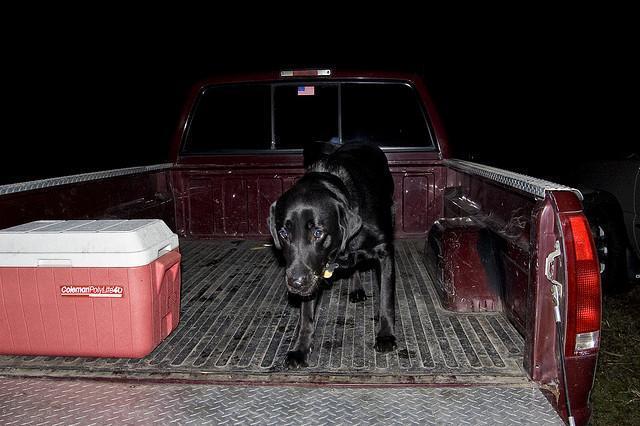How many dogs are there?
Give a very brief answer. 1. How many people does this car hold?
Give a very brief answer. 0. 